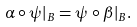Convert formula to latex. <formula><loc_0><loc_0><loc_500><loc_500>\alpha \circ \psi | _ { B } = \psi \circ \beta | _ { B } .</formula> 